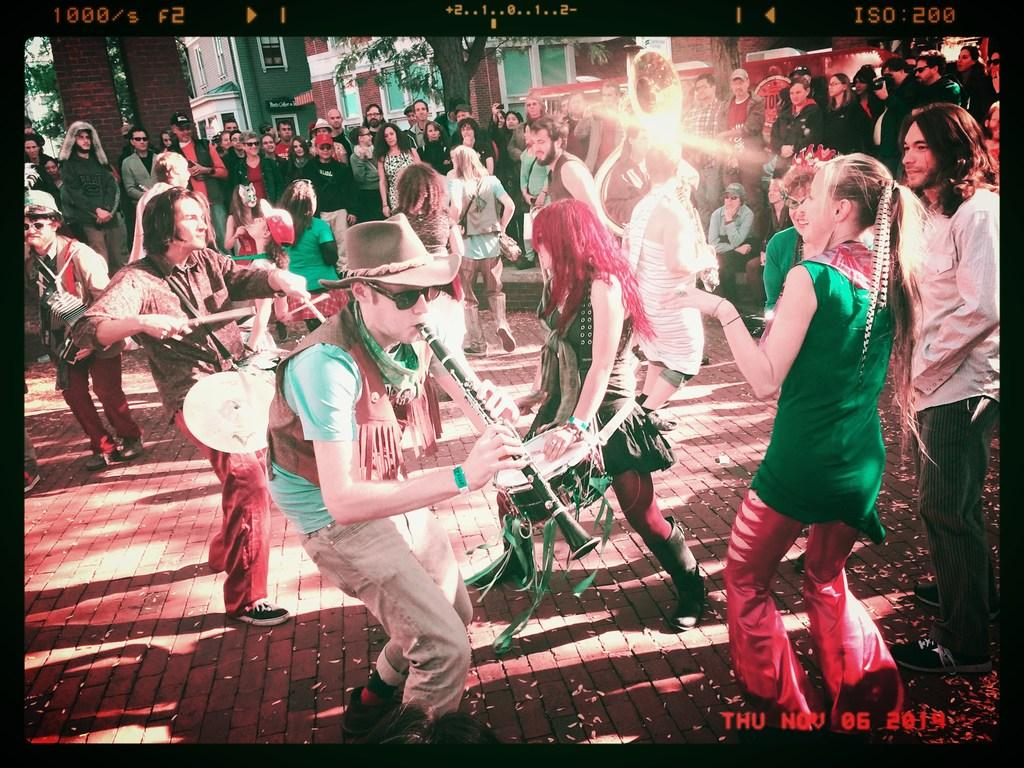How many people are in the image? There are people in the image, but the exact number is not specified. What are some of the people doing in the image? Some people are playing musical instruments in the image. What can be seen in the background of the image? There are buildings and trees in the background of the image. What type of profit does the uncle make from the musical instruments in the image? There is no mention of an uncle or profit in the image, so this question cannot be answered. 